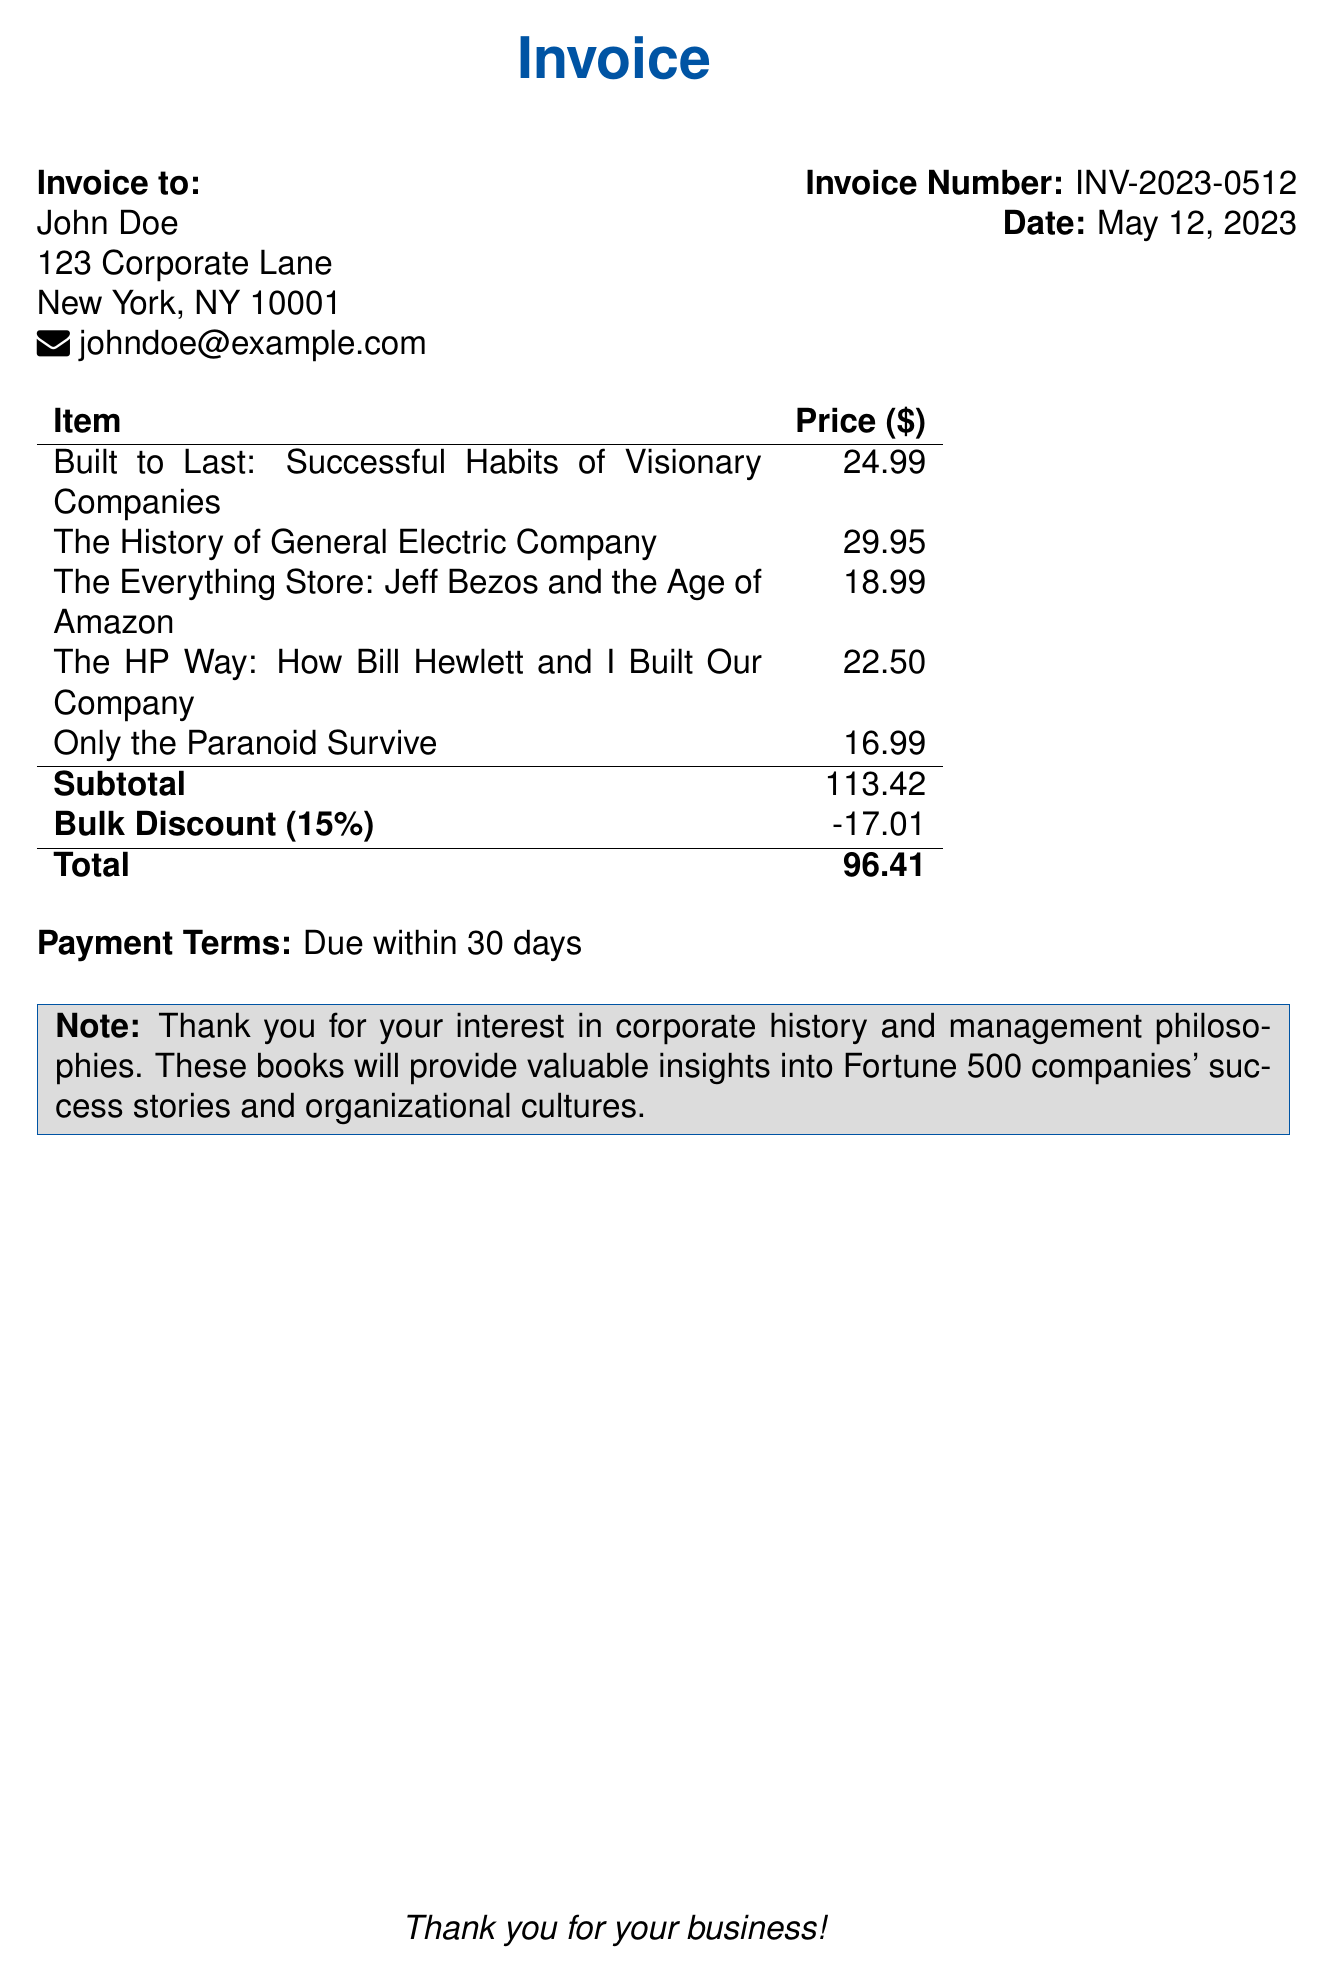What is the total amount due? The total amount due is found in the invoice at the bottom line, which is listed as the final total after discounts.
Answer: 96.41 Who is the invoice addressed to? The invoice shows the recipient's name at the top left section, indicating to whom the invoice is addressed.
Answer: John Doe What is the discount percentage applied? The discount percentage is mentioned right above the total, reflecting the reduction from the subtotal.
Answer: 15% What is the subtotal of the items before the discount? The subtotal is explicitly listed before any discounts are applied in the table of items.
Answer: 113.42 What is the invoice number? The invoice number is stated clearly under the invoice date, identifying this specific transaction.
Answer: INV-2023-0512 When is the payment due? The payment terms indicate the timeframe within which the payment should be made, as noted in the document.
Answer: 30 days How many books are included in the invoice? The number of books can be inferred from the individual item entries in the invoice table.
Answer: 5 What is the purpose of the note in the document? The note serves as a thank you and provides context about the subject matter of the purchased books.
Answer: Appreciation for interest in corporate history and management philosophies 